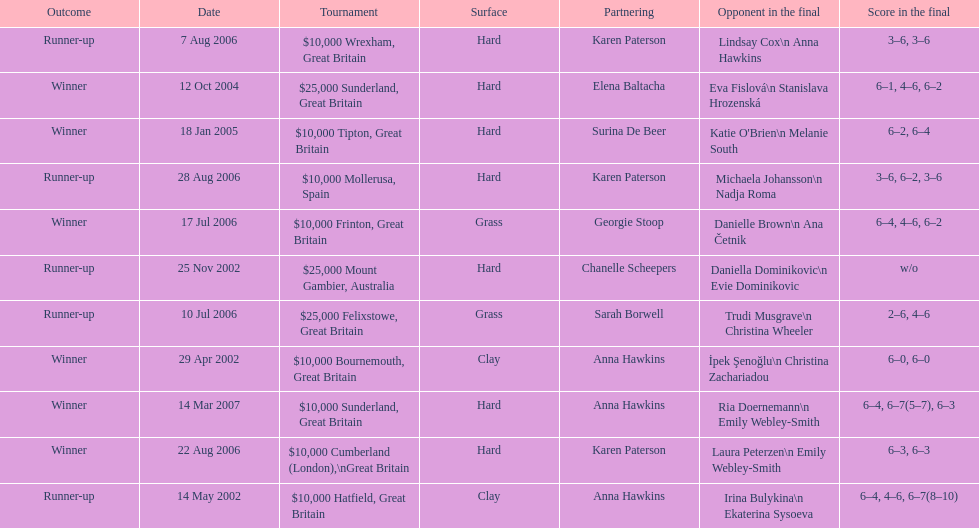Could you parse the entire table? {'header': ['Outcome', 'Date', 'Tournament', 'Surface', 'Partnering', 'Opponent in the final', 'Score in the final'], 'rows': [['Runner-up', '7 Aug 2006', '$10,000 Wrexham, Great Britain', 'Hard', 'Karen Paterson', 'Lindsay Cox\\n Anna Hawkins', '3–6, 3–6'], ['Winner', '12 Oct 2004', '$25,000 Sunderland, Great Britain', 'Hard', 'Elena Baltacha', 'Eva Fislová\\n Stanislava Hrozenská', '6–1, 4–6, 6–2'], ['Winner', '18 Jan 2005', '$10,000 Tipton, Great Britain', 'Hard', 'Surina De Beer', "Katie O'Brien\\n Melanie South", '6–2, 6–4'], ['Runner-up', '28 Aug 2006', '$10,000 Mollerusa, Spain', 'Hard', 'Karen Paterson', 'Michaela Johansson\\n Nadja Roma', '3–6, 6–2, 3–6'], ['Winner', '17 Jul 2006', '$10,000 Frinton, Great Britain', 'Grass', 'Georgie Stoop', 'Danielle Brown\\n Ana Četnik', '6–4, 4–6, 6–2'], ['Runner-up', '25 Nov 2002', '$25,000 Mount Gambier, Australia', 'Hard', 'Chanelle Scheepers', 'Daniella Dominikovic\\n Evie Dominikovic', 'w/o'], ['Runner-up', '10 Jul 2006', '$25,000 Felixstowe, Great Britain', 'Grass', 'Sarah Borwell', 'Trudi Musgrave\\n Christina Wheeler', '2–6, 4–6'], ['Winner', '29 Apr 2002', '$10,000 Bournemouth, Great Britain', 'Clay', 'Anna Hawkins', 'İpek Şenoğlu\\n Christina Zachariadou', '6–0, 6–0'], ['Winner', '14 Mar 2007', '$10,000 Sunderland, Great Britain', 'Hard', 'Anna Hawkins', 'Ria Doernemann\\n Emily Webley-Smith', '6–4, 6–7(5–7), 6–3'], ['Winner', '22 Aug 2006', '$10,000 Cumberland (London),\\nGreat Britain', 'Hard', 'Karen Paterson', 'Laura Peterzen\\n Emily Webley-Smith', '6–3, 6–3'], ['Runner-up', '14 May 2002', '$10,000 Hatfield, Great Britain', 'Clay', 'Anna Hawkins', 'Irina Bulykina\\n Ekaterina Sysoeva', '6–4, 4–6, 6–7(8–10)']]} How many surfaces are grass? 2. 